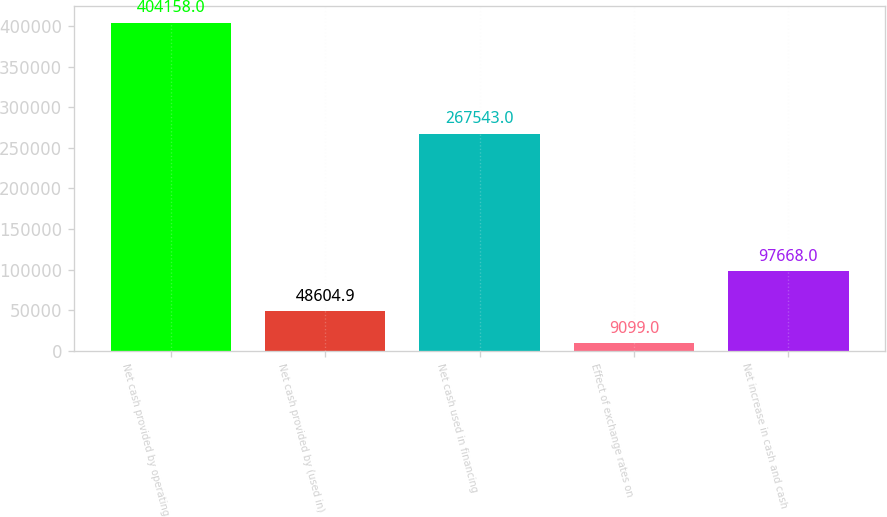Convert chart to OTSL. <chart><loc_0><loc_0><loc_500><loc_500><bar_chart><fcel>Net cash provided by operating<fcel>Net cash provided by (used in)<fcel>Net cash used in financing<fcel>Effect of exchange rates on<fcel>Net increase in cash and cash<nl><fcel>404158<fcel>48604.9<fcel>267543<fcel>9099<fcel>97668<nl></chart> 